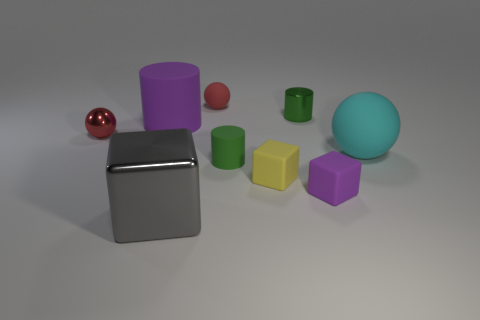Subtract all shiny spheres. How many spheres are left? 2 Add 1 green matte objects. How many objects exist? 10 Subtract 1 cylinders. How many cylinders are left? 2 Subtract all green cylinders. How many cylinders are left? 1 Subtract all cubes. How many objects are left? 6 Subtract 0 gray balls. How many objects are left? 9 Subtract all red cubes. Subtract all cyan spheres. How many cubes are left? 3 Subtract all gray cylinders. How many red balls are left? 2 Subtract all large purple shiny cylinders. Subtract all small purple objects. How many objects are left? 8 Add 3 small cylinders. How many small cylinders are left? 5 